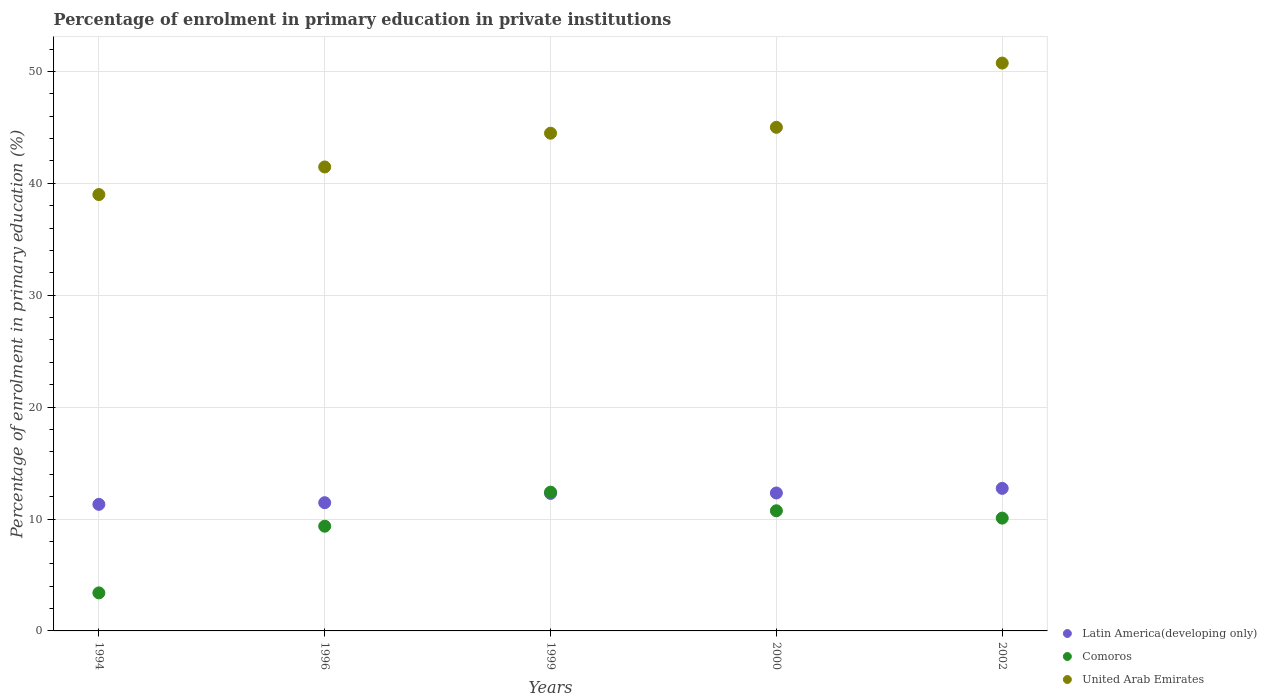Is the number of dotlines equal to the number of legend labels?
Ensure brevity in your answer.  Yes. What is the percentage of enrolment in primary education in United Arab Emirates in 2000?
Your answer should be very brief. 45. Across all years, what is the maximum percentage of enrolment in primary education in United Arab Emirates?
Provide a succinct answer. 50.75. Across all years, what is the minimum percentage of enrolment in primary education in United Arab Emirates?
Provide a short and direct response. 38.99. In which year was the percentage of enrolment in primary education in United Arab Emirates minimum?
Provide a succinct answer. 1994. What is the total percentage of enrolment in primary education in Comoros in the graph?
Offer a terse response. 45.97. What is the difference between the percentage of enrolment in primary education in Comoros in 1999 and that in 2000?
Offer a terse response. 1.67. What is the difference between the percentage of enrolment in primary education in United Arab Emirates in 1999 and the percentage of enrolment in primary education in Latin America(developing only) in 2000?
Keep it short and to the point. 32.15. What is the average percentage of enrolment in primary education in Latin America(developing only) per year?
Ensure brevity in your answer.  12.02. In the year 1999, what is the difference between the percentage of enrolment in primary education in Latin America(developing only) and percentage of enrolment in primary education in United Arab Emirates?
Offer a terse response. -32.19. In how many years, is the percentage of enrolment in primary education in United Arab Emirates greater than 4 %?
Give a very brief answer. 5. What is the ratio of the percentage of enrolment in primary education in Latin America(developing only) in 2000 to that in 2002?
Provide a short and direct response. 0.97. Is the difference between the percentage of enrolment in primary education in Latin America(developing only) in 1994 and 2002 greater than the difference between the percentage of enrolment in primary education in United Arab Emirates in 1994 and 2002?
Your response must be concise. Yes. What is the difference between the highest and the second highest percentage of enrolment in primary education in Comoros?
Offer a very short reply. 1.67. What is the difference between the highest and the lowest percentage of enrolment in primary education in Latin America(developing only)?
Keep it short and to the point. 1.43. Is the percentage of enrolment in primary education in Comoros strictly less than the percentage of enrolment in primary education in Latin America(developing only) over the years?
Your response must be concise. No. What is the difference between two consecutive major ticks on the Y-axis?
Ensure brevity in your answer.  10. Does the graph contain grids?
Ensure brevity in your answer.  Yes. How many legend labels are there?
Make the answer very short. 3. What is the title of the graph?
Offer a very short reply. Percentage of enrolment in primary education in private institutions. What is the label or title of the X-axis?
Give a very brief answer. Years. What is the label or title of the Y-axis?
Your response must be concise. Percentage of enrolment in primary education (%). What is the Percentage of enrolment in primary education (%) of Latin America(developing only) in 1994?
Provide a succinct answer. 11.31. What is the Percentage of enrolment in primary education (%) in Comoros in 1994?
Provide a short and direct response. 3.4. What is the Percentage of enrolment in primary education (%) of United Arab Emirates in 1994?
Offer a terse response. 38.99. What is the Percentage of enrolment in primary education (%) of Latin America(developing only) in 1996?
Your answer should be compact. 11.46. What is the Percentage of enrolment in primary education (%) of Comoros in 1996?
Your answer should be very brief. 9.36. What is the Percentage of enrolment in primary education (%) in United Arab Emirates in 1996?
Make the answer very short. 41.46. What is the Percentage of enrolment in primary education (%) in Latin America(developing only) in 1999?
Offer a terse response. 12.28. What is the Percentage of enrolment in primary education (%) in Comoros in 1999?
Offer a very short reply. 12.4. What is the Percentage of enrolment in primary education (%) of United Arab Emirates in 1999?
Provide a short and direct response. 44.48. What is the Percentage of enrolment in primary education (%) in Latin America(developing only) in 2000?
Provide a short and direct response. 12.33. What is the Percentage of enrolment in primary education (%) in Comoros in 2000?
Offer a terse response. 10.74. What is the Percentage of enrolment in primary education (%) in United Arab Emirates in 2000?
Your response must be concise. 45. What is the Percentage of enrolment in primary education (%) in Latin America(developing only) in 2002?
Keep it short and to the point. 12.74. What is the Percentage of enrolment in primary education (%) in Comoros in 2002?
Ensure brevity in your answer.  10.08. What is the Percentage of enrolment in primary education (%) of United Arab Emirates in 2002?
Keep it short and to the point. 50.75. Across all years, what is the maximum Percentage of enrolment in primary education (%) of Latin America(developing only)?
Make the answer very short. 12.74. Across all years, what is the maximum Percentage of enrolment in primary education (%) in Comoros?
Offer a very short reply. 12.4. Across all years, what is the maximum Percentage of enrolment in primary education (%) in United Arab Emirates?
Ensure brevity in your answer.  50.75. Across all years, what is the minimum Percentage of enrolment in primary education (%) in Latin America(developing only)?
Provide a short and direct response. 11.31. Across all years, what is the minimum Percentage of enrolment in primary education (%) in Comoros?
Offer a terse response. 3.4. Across all years, what is the minimum Percentage of enrolment in primary education (%) of United Arab Emirates?
Keep it short and to the point. 38.99. What is the total Percentage of enrolment in primary education (%) of Latin America(developing only) in the graph?
Keep it short and to the point. 60.12. What is the total Percentage of enrolment in primary education (%) of Comoros in the graph?
Offer a terse response. 45.97. What is the total Percentage of enrolment in primary education (%) in United Arab Emirates in the graph?
Your answer should be very brief. 220.68. What is the difference between the Percentage of enrolment in primary education (%) in Latin America(developing only) in 1994 and that in 1996?
Offer a terse response. -0.15. What is the difference between the Percentage of enrolment in primary education (%) in Comoros in 1994 and that in 1996?
Your answer should be very brief. -5.96. What is the difference between the Percentage of enrolment in primary education (%) of United Arab Emirates in 1994 and that in 1996?
Make the answer very short. -2.47. What is the difference between the Percentage of enrolment in primary education (%) in Latin America(developing only) in 1994 and that in 1999?
Ensure brevity in your answer.  -0.97. What is the difference between the Percentage of enrolment in primary education (%) in Comoros in 1994 and that in 1999?
Offer a very short reply. -9. What is the difference between the Percentage of enrolment in primary education (%) in United Arab Emirates in 1994 and that in 1999?
Your answer should be very brief. -5.48. What is the difference between the Percentage of enrolment in primary education (%) of Latin America(developing only) in 1994 and that in 2000?
Keep it short and to the point. -1.01. What is the difference between the Percentage of enrolment in primary education (%) in Comoros in 1994 and that in 2000?
Keep it short and to the point. -7.34. What is the difference between the Percentage of enrolment in primary education (%) of United Arab Emirates in 1994 and that in 2000?
Provide a succinct answer. -6.01. What is the difference between the Percentage of enrolment in primary education (%) in Latin America(developing only) in 1994 and that in 2002?
Ensure brevity in your answer.  -1.43. What is the difference between the Percentage of enrolment in primary education (%) in Comoros in 1994 and that in 2002?
Your response must be concise. -6.68. What is the difference between the Percentage of enrolment in primary education (%) of United Arab Emirates in 1994 and that in 2002?
Keep it short and to the point. -11.75. What is the difference between the Percentage of enrolment in primary education (%) in Latin America(developing only) in 1996 and that in 1999?
Your answer should be compact. -0.83. What is the difference between the Percentage of enrolment in primary education (%) of Comoros in 1996 and that in 1999?
Keep it short and to the point. -3.04. What is the difference between the Percentage of enrolment in primary education (%) of United Arab Emirates in 1996 and that in 1999?
Make the answer very short. -3.02. What is the difference between the Percentage of enrolment in primary education (%) of Latin America(developing only) in 1996 and that in 2000?
Provide a succinct answer. -0.87. What is the difference between the Percentage of enrolment in primary education (%) in Comoros in 1996 and that in 2000?
Your answer should be compact. -1.38. What is the difference between the Percentage of enrolment in primary education (%) in United Arab Emirates in 1996 and that in 2000?
Give a very brief answer. -3.54. What is the difference between the Percentage of enrolment in primary education (%) in Latin America(developing only) in 1996 and that in 2002?
Ensure brevity in your answer.  -1.28. What is the difference between the Percentage of enrolment in primary education (%) of Comoros in 1996 and that in 2002?
Offer a terse response. -0.72. What is the difference between the Percentage of enrolment in primary education (%) in United Arab Emirates in 1996 and that in 2002?
Provide a short and direct response. -9.28. What is the difference between the Percentage of enrolment in primary education (%) of Latin America(developing only) in 1999 and that in 2000?
Keep it short and to the point. -0.04. What is the difference between the Percentage of enrolment in primary education (%) of Comoros in 1999 and that in 2000?
Provide a short and direct response. 1.67. What is the difference between the Percentage of enrolment in primary education (%) in United Arab Emirates in 1999 and that in 2000?
Offer a very short reply. -0.53. What is the difference between the Percentage of enrolment in primary education (%) in Latin America(developing only) in 1999 and that in 2002?
Keep it short and to the point. -0.45. What is the difference between the Percentage of enrolment in primary education (%) in Comoros in 1999 and that in 2002?
Make the answer very short. 2.32. What is the difference between the Percentage of enrolment in primary education (%) of United Arab Emirates in 1999 and that in 2002?
Your answer should be very brief. -6.27. What is the difference between the Percentage of enrolment in primary education (%) of Latin America(developing only) in 2000 and that in 2002?
Your answer should be compact. -0.41. What is the difference between the Percentage of enrolment in primary education (%) of Comoros in 2000 and that in 2002?
Provide a short and direct response. 0.66. What is the difference between the Percentage of enrolment in primary education (%) in United Arab Emirates in 2000 and that in 2002?
Ensure brevity in your answer.  -5.74. What is the difference between the Percentage of enrolment in primary education (%) of Latin America(developing only) in 1994 and the Percentage of enrolment in primary education (%) of Comoros in 1996?
Your answer should be compact. 1.95. What is the difference between the Percentage of enrolment in primary education (%) in Latin America(developing only) in 1994 and the Percentage of enrolment in primary education (%) in United Arab Emirates in 1996?
Your response must be concise. -30.15. What is the difference between the Percentage of enrolment in primary education (%) in Comoros in 1994 and the Percentage of enrolment in primary education (%) in United Arab Emirates in 1996?
Give a very brief answer. -38.06. What is the difference between the Percentage of enrolment in primary education (%) of Latin America(developing only) in 1994 and the Percentage of enrolment in primary education (%) of Comoros in 1999?
Keep it short and to the point. -1.09. What is the difference between the Percentage of enrolment in primary education (%) in Latin America(developing only) in 1994 and the Percentage of enrolment in primary education (%) in United Arab Emirates in 1999?
Offer a very short reply. -33.17. What is the difference between the Percentage of enrolment in primary education (%) of Comoros in 1994 and the Percentage of enrolment in primary education (%) of United Arab Emirates in 1999?
Provide a succinct answer. -41.08. What is the difference between the Percentage of enrolment in primary education (%) of Latin America(developing only) in 1994 and the Percentage of enrolment in primary education (%) of Comoros in 2000?
Provide a succinct answer. 0.57. What is the difference between the Percentage of enrolment in primary education (%) in Latin America(developing only) in 1994 and the Percentage of enrolment in primary education (%) in United Arab Emirates in 2000?
Offer a very short reply. -33.69. What is the difference between the Percentage of enrolment in primary education (%) in Comoros in 1994 and the Percentage of enrolment in primary education (%) in United Arab Emirates in 2000?
Offer a very short reply. -41.61. What is the difference between the Percentage of enrolment in primary education (%) in Latin America(developing only) in 1994 and the Percentage of enrolment in primary education (%) in Comoros in 2002?
Give a very brief answer. 1.23. What is the difference between the Percentage of enrolment in primary education (%) in Latin America(developing only) in 1994 and the Percentage of enrolment in primary education (%) in United Arab Emirates in 2002?
Your response must be concise. -39.43. What is the difference between the Percentage of enrolment in primary education (%) of Comoros in 1994 and the Percentage of enrolment in primary education (%) of United Arab Emirates in 2002?
Give a very brief answer. -47.35. What is the difference between the Percentage of enrolment in primary education (%) in Latin America(developing only) in 1996 and the Percentage of enrolment in primary education (%) in Comoros in 1999?
Make the answer very short. -0.94. What is the difference between the Percentage of enrolment in primary education (%) of Latin America(developing only) in 1996 and the Percentage of enrolment in primary education (%) of United Arab Emirates in 1999?
Offer a very short reply. -33.02. What is the difference between the Percentage of enrolment in primary education (%) in Comoros in 1996 and the Percentage of enrolment in primary education (%) in United Arab Emirates in 1999?
Offer a very short reply. -35.12. What is the difference between the Percentage of enrolment in primary education (%) in Latin America(developing only) in 1996 and the Percentage of enrolment in primary education (%) in Comoros in 2000?
Ensure brevity in your answer.  0.72. What is the difference between the Percentage of enrolment in primary education (%) in Latin America(developing only) in 1996 and the Percentage of enrolment in primary education (%) in United Arab Emirates in 2000?
Your response must be concise. -33.55. What is the difference between the Percentage of enrolment in primary education (%) in Comoros in 1996 and the Percentage of enrolment in primary education (%) in United Arab Emirates in 2000?
Offer a terse response. -35.65. What is the difference between the Percentage of enrolment in primary education (%) in Latin America(developing only) in 1996 and the Percentage of enrolment in primary education (%) in Comoros in 2002?
Make the answer very short. 1.38. What is the difference between the Percentage of enrolment in primary education (%) in Latin America(developing only) in 1996 and the Percentage of enrolment in primary education (%) in United Arab Emirates in 2002?
Ensure brevity in your answer.  -39.29. What is the difference between the Percentage of enrolment in primary education (%) of Comoros in 1996 and the Percentage of enrolment in primary education (%) of United Arab Emirates in 2002?
Your answer should be compact. -41.39. What is the difference between the Percentage of enrolment in primary education (%) in Latin America(developing only) in 1999 and the Percentage of enrolment in primary education (%) in Comoros in 2000?
Provide a short and direct response. 1.55. What is the difference between the Percentage of enrolment in primary education (%) of Latin America(developing only) in 1999 and the Percentage of enrolment in primary education (%) of United Arab Emirates in 2000?
Your answer should be very brief. -32.72. What is the difference between the Percentage of enrolment in primary education (%) of Comoros in 1999 and the Percentage of enrolment in primary education (%) of United Arab Emirates in 2000?
Your answer should be compact. -32.6. What is the difference between the Percentage of enrolment in primary education (%) in Latin America(developing only) in 1999 and the Percentage of enrolment in primary education (%) in Comoros in 2002?
Your answer should be very brief. 2.2. What is the difference between the Percentage of enrolment in primary education (%) of Latin America(developing only) in 1999 and the Percentage of enrolment in primary education (%) of United Arab Emirates in 2002?
Your answer should be very brief. -38.46. What is the difference between the Percentage of enrolment in primary education (%) in Comoros in 1999 and the Percentage of enrolment in primary education (%) in United Arab Emirates in 2002?
Keep it short and to the point. -38.34. What is the difference between the Percentage of enrolment in primary education (%) of Latin America(developing only) in 2000 and the Percentage of enrolment in primary education (%) of Comoros in 2002?
Offer a very short reply. 2.25. What is the difference between the Percentage of enrolment in primary education (%) of Latin America(developing only) in 2000 and the Percentage of enrolment in primary education (%) of United Arab Emirates in 2002?
Your response must be concise. -38.42. What is the difference between the Percentage of enrolment in primary education (%) of Comoros in 2000 and the Percentage of enrolment in primary education (%) of United Arab Emirates in 2002?
Ensure brevity in your answer.  -40.01. What is the average Percentage of enrolment in primary education (%) of Latin America(developing only) per year?
Offer a terse response. 12.02. What is the average Percentage of enrolment in primary education (%) of Comoros per year?
Keep it short and to the point. 9.19. What is the average Percentage of enrolment in primary education (%) of United Arab Emirates per year?
Provide a short and direct response. 44.14. In the year 1994, what is the difference between the Percentage of enrolment in primary education (%) in Latin America(developing only) and Percentage of enrolment in primary education (%) in Comoros?
Offer a very short reply. 7.91. In the year 1994, what is the difference between the Percentage of enrolment in primary education (%) of Latin America(developing only) and Percentage of enrolment in primary education (%) of United Arab Emirates?
Ensure brevity in your answer.  -27.68. In the year 1994, what is the difference between the Percentage of enrolment in primary education (%) of Comoros and Percentage of enrolment in primary education (%) of United Arab Emirates?
Provide a succinct answer. -35.6. In the year 1996, what is the difference between the Percentage of enrolment in primary education (%) of Latin America(developing only) and Percentage of enrolment in primary education (%) of Comoros?
Your answer should be very brief. 2.1. In the year 1996, what is the difference between the Percentage of enrolment in primary education (%) in Latin America(developing only) and Percentage of enrolment in primary education (%) in United Arab Emirates?
Offer a very short reply. -30. In the year 1996, what is the difference between the Percentage of enrolment in primary education (%) in Comoros and Percentage of enrolment in primary education (%) in United Arab Emirates?
Give a very brief answer. -32.1. In the year 1999, what is the difference between the Percentage of enrolment in primary education (%) in Latin America(developing only) and Percentage of enrolment in primary education (%) in Comoros?
Make the answer very short. -0.12. In the year 1999, what is the difference between the Percentage of enrolment in primary education (%) of Latin America(developing only) and Percentage of enrolment in primary education (%) of United Arab Emirates?
Your answer should be compact. -32.19. In the year 1999, what is the difference between the Percentage of enrolment in primary education (%) of Comoros and Percentage of enrolment in primary education (%) of United Arab Emirates?
Keep it short and to the point. -32.08. In the year 2000, what is the difference between the Percentage of enrolment in primary education (%) of Latin America(developing only) and Percentage of enrolment in primary education (%) of Comoros?
Keep it short and to the point. 1.59. In the year 2000, what is the difference between the Percentage of enrolment in primary education (%) of Latin America(developing only) and Percentage of enrolment in primary education (%) of United Arab Emirates?
Ensure brevity in your answer.  -32.68. In the year 2000, what is the difference between the Percentage of enrolment in primary education (%) in Comoros and Percentage of enrolment in primary education (%) in United Arab Emirates?
Your answer should be very brief. -34.27. In the year 2002, what is the difference between the Percentage of enrolment in primary education (%) in Latin America(developing only) and Percentage of enrolment in primary education (%) in Comoros?
Your answer should be very brief. 2.66. In the year 2002, what is the difference between the Percentage of enrolment in primary education (%) in Latin America(developing only) and Percentage of enrolment in primary education (%) in United Arab Emirates?
Offer a very short reply. -38.01. In the year 2002, what is the difference between the Percentage of enrolment in primary education (%) of Comoros and Percentage of enrolment in primary education (%) of United Arab Emirates?
Offer a terse response. -40.66. What is the ratio of the Percentage of enrolment in primary education (%) in Latin America(developing only) in 1994 to that in 1996?
Provide a short and direct response. 0.99. What is the ratio of the Percentage of enrolment in primary education (%) of Comoros in 1994 to that in 1996?
Your response must be concise. 0.36. What is the ratio of the Percentage of enrolment in primary education (%) in United Arab Emirates in 1994 to that in 1996?
Provide a succinct answer. 0.94. What is the ratio of the Percentage of enrolment in primary education (%) in Latin America(developing only) in 1994 to that in 1999?
Provide a short and direct response. 0.92. What is the ratio of the Percentage of enrolment in primary education (%) in Comoros in 1994 to that in 1999?
Your answer should be compact. 0.27. What is the ratio of the Percentage of enrolment in primary education (%) in United Arab Emirates in 1994 to that in 1999?
Your answer should be compact. 0.88. What is the ratio of the Percentage of enrolment in primary education (%) in Latin America(developing only) in 1994 to that in 2000?
Your answer should be compact. 0.92. What is the ratio of the Percentage of enrolment in primary education (%) in Comoros in 1994 to that in 2000?
Offer a terse response. 0.32. What is the ratio of the Percentage of enrolment in primary education (%) in United Arab Emirates in 1994 to that in 2000?
Provide a short and direct response. 0.87. What is the ratio of the Percentage of enrolment in primary education (%) in Latin America(developing only) in 1994 to that in 2002?
Make the answer very short. 0.89. What is the ratio of the Percentage of enrolment in primary education (%) of Comoros in 1994 to that in 2002?
Offer a very short reply. 0.34. What is the ratio of the Percentage of enrolment in primary education (%) of United Arab Emirates in 1994 to that in 2002?
Your answer should be compact. 0.77. What is the ratio of the Percentage of enrolment in primary education (%) of Latin America(developing only) in 1996 to that in 1999?
Give a very brief answer. 0.93. What is the ratio of the Percentage of enrolment in primary education (%) of Comoros in 1996 to that in 1999?
Keep it short and to the point. 0.75. What is the ratio of the Percentage of enrolment in primary education (%) of United Arab Emirates in 1996 to that in 1999?
Offer a terse response. 0.93. What is the ratio of the Percentage of enrolment in primary education (%) of Latin America(developing only) in 1996 to that in 2000?
Your answer should be very brief. 0.93. What is the ratio of the Percentage of enrolment in primary education (%) of Comoros in 1996 to that in 2000?
Offer a very short reply. 0.87. What is the ratio of the Percentage of enrolment in primary education (%) of United Arab Emirates in 1996 to that in 2000?
Your answer should be compact. 0.92. What is the ratio of the Percentage of enrolment in primary education (%) of Latin America(developing only) in 1996 to that in 2002?
Keep it short and to the point. 0.9. What is the ratio of the Percentage of enrolment in primary education (%) of Comoros in 1996 to that in 2002?
Provide a short and direct response. 0.93. What is the ratio of the Percentage of enrolment in primary education (%) in United Arab Emirates in 1996 to that in 2002?
Provide a short and direct response. 0.82. What is the ratio of the Percentage of enrolment in primary education (%) of Latin America(developing only) in 1999 to that in 2000?
Provide a short and direct response. 1. What is the ratio of the Percentage of enrolment in primary education (%) of Comoros in 1999 to that in 2000?
Your answer should be compact. 1.16. What is the ratio of the Percentage of enrolment in primary education (%) of United Arab Emirates in 1999 to that in 2000?
Keep it short and to the point. 0.99. What is the ratio of the Percentage of enrolment in primary education (%) of Latin America(developing only) in 1999 to that in 2002?
Offer a very short reply. 0.96. What is the ratio of the Percentage of enrolment in primary education (%) of Comoros in 1999 to that in 2002?
Ensure brevity in your answer.  1.23. What is the ratio of the Percentage of enrolment in primary education (%) of United Arab Emirates in 1999 to that in 2002?
Offer a terse response. 0.88. What is the ratio of the Percentage of enrolment in primary education (%) of Latin America(developing only) in 2000 to that in 2002?
Offer a terse response. 0.97. What is the ratio of the Percentage of enrolment in primary education (%) of Comoros in 2000 to that in 2002?
Provide a succinct answer. 1.07. What is the ratio of the Percentage of enrolment in primary education (%) of United Arab Emirates in 2000 to that in 2002?
Offer a terse response. 0.89. What is the difference between the highest and the second highest Percentage of enrolment in primary education (%) of Latin America(developing only)?
Keep it short and to the point. 0.41. What is the difference between the highest and the second highest Percentage of enrolment in primary education (%) in Comoros?
Ensure brevity in your answer.  1.67. What is the difference between the highest and the second highest Percentage of enrolment in primary education (%) in United Arab Emirates?
Your answer should be compact. 5.74. What is the difference between the highest and the lowest Percentage of enrolment in primary education (%) in Latin America(developing only)?
Provide a short and direct response. 1.43. What is the difference between the highest and the lowest Percentage of enrolment in primary education (%) of Comoros?
Offer a terse response. 9. What is the difference between the highest and the lowest Percentage of enrolment in primary education (%) in United Arab Emirates?
Your answer should be very brief. 11.75. 